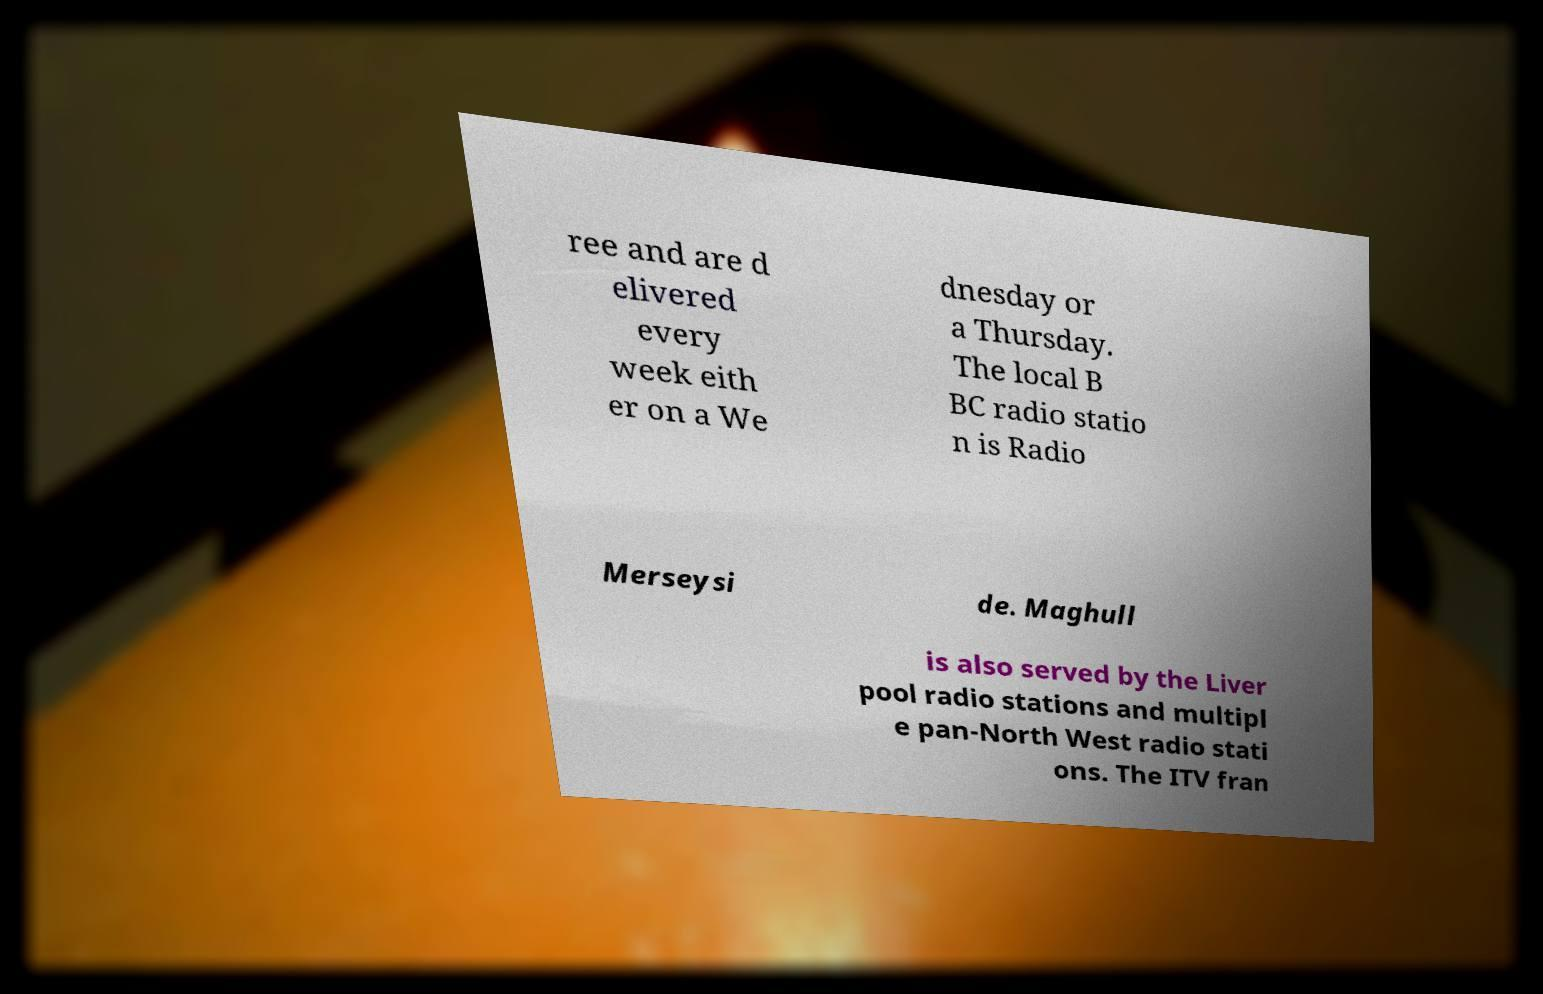Could you assist in decoding the text presented in this image and type it out clearly? ree and are d elivered every week eith er on a We dnesday or a Thursday. The local B BC radio statio n is Radio Merseysi de. Maghull is also served by the Liver pool radio stations and multipl e pan-North West radio stati ons. The ITV fran 